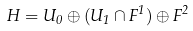Convert formula to latex. <formula><loc_0><loc_0><loc_500><loc_500>H = U _ { 0 } \oplus ( U _ { 1 } \cap F ^ { 1 } ) \oplus F ^ { 2 }</formula> 